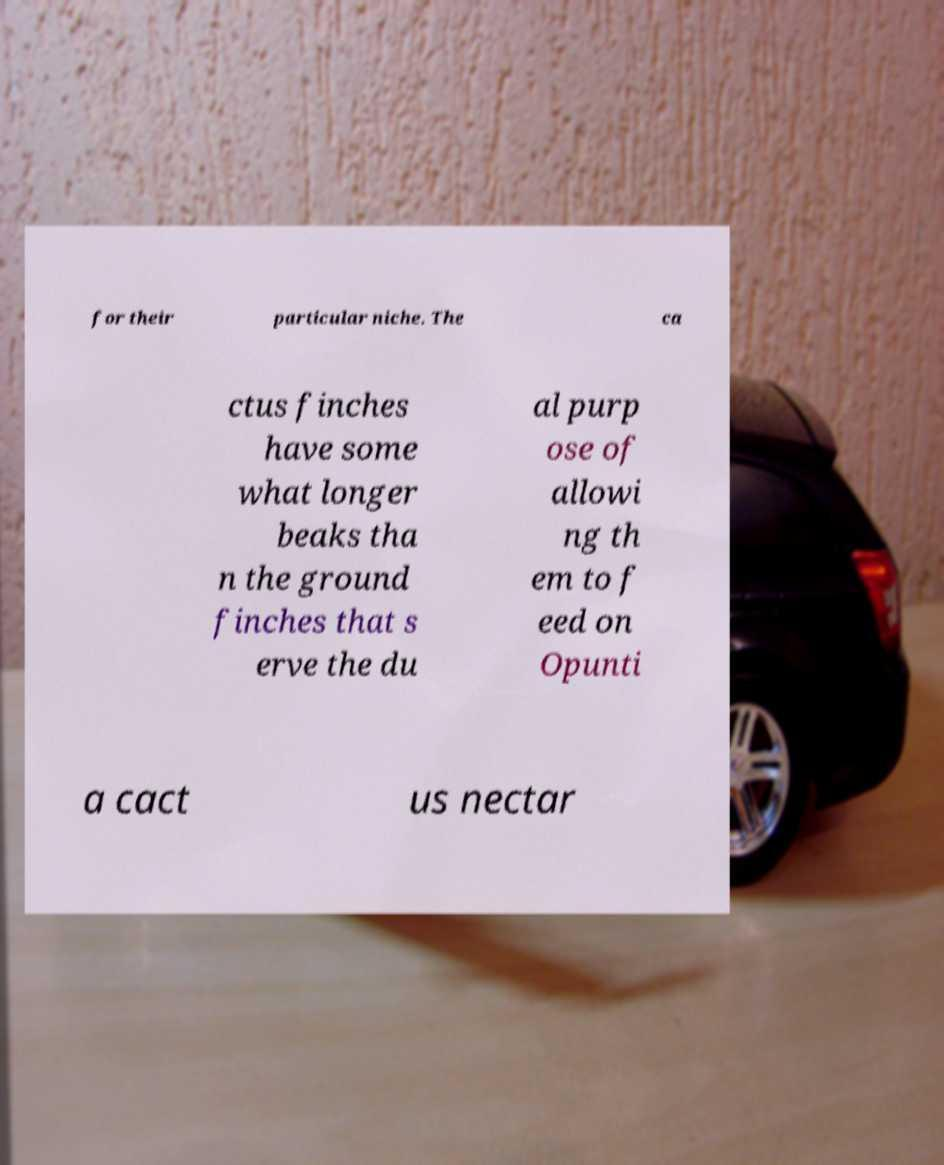There's text embedded in this image that I need extracted. Can you transcribe it verbatim? for their particular niche. The ca ctus finches have some what longer beaks tha n the ground finches that s erve the du al purp ose of allowi ng th em to f eed on Opunti a cact us nectar 